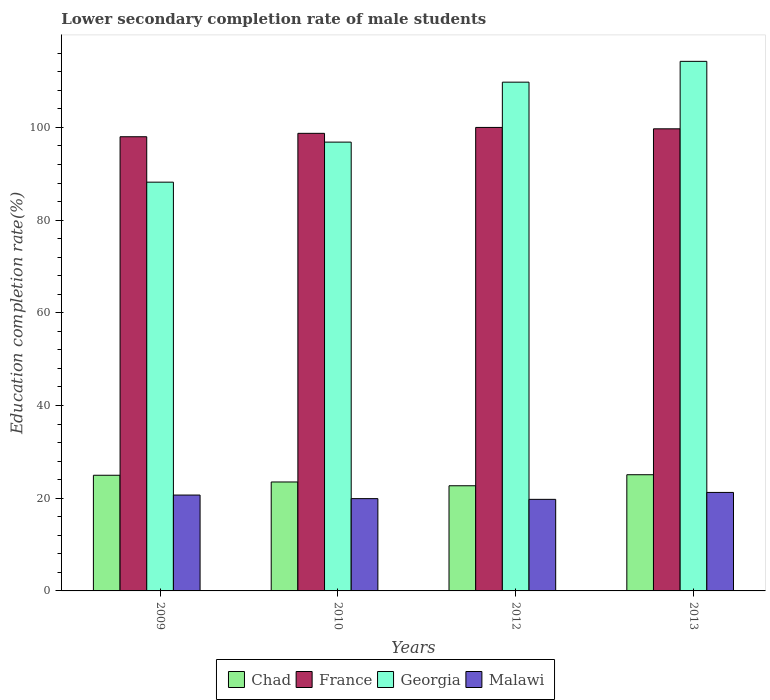Are the number of bars per tick equal to the number of legend labels?
Provide a succinct answer. Yes. Are the number of bars on each tick of the X-axis equal?
Your answer should be compact. Yes. What is the label of the 3rd group of bars from the left?
Provide a short and direct response. 2012. What is the lower secondary completion rate of male students in Malawi in 2009?
Your answer should be compact. 20.68. Across all years, what is the maximum lower secondary completion rate of male students in Chad?
Keep it short and to the point. 25.07. Across all years, what is the minimum lower secondary completion rate of male students in Malawi?
Offer a very short reply. 19.75. In which year was the lower secondary completion rate of male students in Chad maximum?
Your answer should be compact. 2013. What is the total lower secondary completion rate of male students in Chad in the graph?
Provide a short and direct response. 96.22. What is the difference between the lower secondary completion rate of male students in Malawi in 2012 and that in 2013?
Offer a terse response. -1.49. What is the difference between the lower secondary completion rate of male students in France in 2012 and the lower secondary completion rate of male students in Chad in 2013?
Your answer should be compact. 74.93. What is the average lower secondary completion rate of male students in France per year?
Your response must be concise. 99.1. In the year 2009, what is the difference between the lower secondary completion rate of male students in France and lower secondary completion rate of male students in Georgia?
Your answer should be compact. 9.8. What is the ratio of the lower secondary completion rate of male students in Georgia in 2009 to that in 2013?
Your answer should be very brief. 0.77. Is the lower secondary completion rate of male students in Georgia in 2010 less than that in 2013?
Offer a very short reply. Yes. Is the difference between the lower secondary completion rate of male students in France in 2010 and 2013 greater than the difference between the lower secondary completion rate of male students in Georgia in 2010 and 2013?
Offer a very short reply. Yes. What is the difference between the highest and the second highest lower secondary completion rate of male students in Georgia?
Your answer should be compact. 4.49. What is the difference between the highest and the lowest lower secondary completion rate of male students in Chad?
Provide a succinct answer. 2.38. In how many years, is the lower secondary completion rate of male students in Malawi greater than the average lower secondary completion rate of male students in Malawi taken over all years?
Your answer should be compact. 2. Is the sum of the lower secondary completion rate of male students in Chad in 2010 and 2013 greater than the maximum lower secondary completion rate of male students in France across all years?
Make the answer very short. No. What does the 4th bar from the left in 2012 represents?
Make the answer very short. Malawi. What does the 1st bar from the right in 2009 represents?
Your answer should be very brief. Malawi. How many bars are there?
Your response must be concise. 16. Are all the bars in the graph horizontal?
Give a very brief answer. No. How many years are there in the graph?
Offer a very short reply. 4. Does the graph contain any zero values?
Make the answer very short. No. Does the graph contain grids?
Your response must be concise. No. How many legend labels are there?
Give a very brief answer. 4. How are the legend labels stacked?
Ensure brevity in your answer.  Horizontal. What is the title of the graph?
Provide a short and direct response. Lower secondary completion rate of male students. Does "Greenland" appear as one of the legend labels in the graph?
Your answer should be compact. No. What is the label or title of the X-axis?
Make the answer very short. Years. What is the label or title of the Y-axis?
Offer a terse response. Education completion rate(%). What is the Education completion rate(%) of Chad in 2009?
Provide a succinct answer. 24.95. What is the Education completion rate(%) of France in 2009?
Make the answer very short. 97.98. What is the Education completion rate(%) of Georgia in 2009?
Offer a very short reply. 88.19. What is the Education completion rate(%) of Malawi in 2009?
Provide a short and direct response. 20.68. What is the Education completion rate(%) of Chad in 2010?
Your answer should be very brief. 23.51. What is the Education completion rate(%) of France in 2010?
Ensure brevity in your answer.  98.72. What is the Education completion rate(%) of Georgia in 2010?
Your response must be concise. 96.83. What is the Education completion rate(%) of Malawi in 2010?
Offer a very short reply. 19.91. What is the Education completion rate(%) in Chad in 2012?
Your answer should be very brief. 22.69. What is the Education completion rate(%) in France in 2012?
Keep it short and to the point. 99.99. What is the Education completion rate(%) in Georgia in 2012?
Your answer should be very brief. 109.76. What is the Education completion rate(%) in Malawi in 2012?
Your response must be concise. 19.75. What is the Education completion rate(%) of Chad in 2013?
Your answer should be very brief. 25.07. What is the Education completion rate(%) of France in 2013?
Your answer should be very brief. 99.7. What is the Education completion rate(%) of Georgia in 2013?
Give a very brief answer. 114.25. What is the Education completion rate(%) in Malawi in 2013?
Your answer should be very brief. 21.25. Across all years, what is the maximum Education completion rate(%) in Chad?
Your answer should be compact. 25.07. Across all years, what is the maximum Education completion rate(%) of France?
Offer a very short reply. 99.99. Across all years, what is the maximum Education completion rate(%) in Georgia?
Give a very brief answer. 114.25. Across all years, what is the maximum Education completion rate(%) in Malawi?
Your response must be concise. 21.25. Across all years, what is the minimum Education completion rate(%) of Chad?
Offer a terse response. 22.69. Across all years, what is the minimum Education completion rate(%) in France?
Offer a terse response. 97.98. Across all years, what is the minimum Education completion rate(%) in Georgia?
Ensure brevity in your answer.  88.19. Across all years, what is the minimum Education completion rate(%) of Malawi?
Keep it short and to the point. 19.75. What is the total Education completion rate(%) of Chad in the graph?
Your answer should be very brief. 96.22. What is the total Education completion rate(%) in France in the graph?
Offer a very short reply. 396.4. What is the total Education completion rate(%) in Georgia in the graph?
Offer a terse response. 409.02. What is the total Education completion rate(%) in Malawi in the graph?
Make the answer very short. 81.6. What is the difference between the Education completion rate(%) of Chad in 2009 and that in 2010?
Offer a very short reply. 1.45. What is the difference between the Education completion rate(%) of France in 2009 and that in 2010?
Give a very brief answer. -0.74. What is the difference between the Education completion rate(%) in Georgia in 2009 and that in 2010?
Make the answer very short. -8.64. What is the difference between the Education completion rate(%) of Malawi in 2009 and that in 2010?
Offer a very short reply. 0.77. What is the difference between the Education completion rate(%) of Chad in 2009 and that in 2012?
Your response must be concise. 2.27. What is the difference between the Education completion rate(%) of France in 2009 and that in 2012?
Your response must be concise. -2.01. What is the difference between the Education completion rate(%) in Georgia in 2009 and that in 2012?
Provide a succinct answer. -21.57. What is the difference between the Education completion rate(%) of Malawi in 2009 and that in 2012?
Keep it short and to the point. 0.93. What is the difference between the Education completion rate(%) in Chad in 2009 and that in 2013?
Ensure brevity in your answer.  -0.11. What is the difference between the Education completion rate(%) in France in 2009 and that in 2013?
Make the answer very short. -1.71. What is the difference between the Education completion rate(%) of Georgia in 2009 and that in 2013?
Your answer should be very brief. -26.07. What is the difference between the Education completion rate(%) of Malawi in 2009 and that in 2013?
Provide a short and direct response. -0.57. What is the difference between the Education completion rate(%) in Chad in 2010 and that in 2012?
Your answer should be very brief. 0.82. What is the difference between the Education completion rate(%) in France in 2010 and that in 2012?
Make the answer very short. -1.27. What is the difference between the Education completion rate(%) in Georgia in 2010 and that in 2012?
Your response must be concise. -12.93. What is the difference between the Education completion rate(%) of Malawi in 2010 and that in 2012?
Your answer should be very brief. 0.16. What is the difference between the Education completion rate(%) of Chad in 2010 and that in 2013?
Keep it short and to the point. -1.56. What is the difference between the Education completion rate(%) in France in 2010 and that in 2013?
Provide a succinct answer. -0.98. What is the difference between the Education completion rate(%) of Georgia in 2010 and that in 2013?
Ensure brevity in your answer.  -17.42. What is the difference between the Education completion rate(%) in Malawi in 2010 and that in 2013?
Keep it short and to the point. -1.34. What is the difference between the Education completion rate(%) in Chad in 2012 and that in 2013?
Provide a succinct answer. -2.38. What is the difference between the Education completion rate(%) of France in 2012 and that in 2013?
Offer a very short reply. 0.3. What is the difference between the Education completion rate(%) of Georgia in 2012 and that in 2013?
Make the answer very short. -4.49. What is the difference between the Education completion rate(%) of Malawi in 2012 and that in 2013?
Offer a terse response. -1.49. What is the difference between the Education completion rate(%) in Chad in 2009 and the Education completion rate(%) in France in 2010?
Your answer should be compact. -73.77. What is the difference between the Education completion rate(%) in Chad in 2009 and the Education completion rate(%) in Georgia in 2010?
Offer a very short reply. -71.87. What is the difference between the Education completion rate(%) of Chad in 2009 and the Education completion rate(%) of Malawi in 2010?
Offer a very short reply. 5.04. What is the difference between the Education completion rate(%) in France in 2009 and the Education completion rate(%) in Georgia in 2010?
Offer a very short reply. 1.16. What is the difference between the Education completion rate(%) in France in 2009 and the Education completion rate(%) in Malawi in 2010?
Keep it short and to the point. 78.07. What is the difference between the Education completion rate(%) of Georgia in 2009 and the Education completion rate(%) of Malawi in 2010?
Your answer should be very brief. 68.27. What is the difference between the Education completion rate(%) in Chad in 2009 and the Education completion rate(%) in France in 2012?
Offer a terse response. -75.04. What is the difference between the Education completion rate(%) in Chad in 2009 and the Education completion rate(%) in Georgia in 2012?
Your answer should be compact. -84.81. What is the difference between the Education completion rate(%) in Chad in 2009 and the Education completion rate(%) in Malawi in 2012?
Keep it short and to the point. 5.2. What is the difference between the Education completion rate(%) of France in 2009 and the Education completion rate(%) of Georgia in 2012?
Your answer should be very brief. -11.78. What is the difference between the Education completion rate(%) in France in 2009 and the Education completion rate(%) in Malawi in 2012?
Provide a short and direct response. 78.23. What is the difference between the Education completion rate(%) in Georgia in 2009 and the Education completion rate(%) in Malawi in 2012?
Your answer should be compact. 68.43. What is the difference between the Education completion rate(%) of Chad in 2009 and the Education completion rate(%) of France in 2013?
Your answer should be very brief. -74.74. What is the difference between the Education completion rate(%) in Chad in 2009 and the Education completion rate(%) in Georgia in 2013?
Ensure brevity in your answer.  -89.3. What is the difference between the Education completion rate(%) of Chad in 2009 and the Education completion rate(%) of Malawi in 2013?
Ensure brevity in your answer.  3.71. What is the difference between the Education completion rate(%) of France in 2009 and the Education completion rate(%) of Georgia in 2013?
Your answer should be very brief. -16.27. What is the difference between the Education completion rate(%) of France in 2009 and the Education completion rate(%) of Malawi in 2013?
Make the answer very short. 76.74. What is the difference between the Education completion rate(%) of Georgia in 2009 and the Education completion rate(%) of Malawi in 2013?
Keep it short and to the point. 66.94. What is the difference between the Education completion rate(%) in Chad in 2010 and the Education completion rate(%) in France in 2012?
Your response must be concise. -76.49. What is the difference between the Education completion rate(%) in Chad in 2010 and the Education completion rate(%) in Georgia in 2012?
Make the answer very short. -86.25. What is the difference between the Education completion rate(%) of Chad in 2010 and the Education completion rate(%) of Malawi in 2012?
Keep it short and to the point. 3.75. What is the difference between the Education completion rate(%) in France in 2010 and the Education completion rate(%) in Georgia in 2012?
Make the answer very short. -11.04. What is the difference between the Education completion rate(%) of France in 2010 and the Education completion rate(%) of Malawi in 2012?
Give a very brief answer. 78.97. What is the difference between the Education completion rate(%) of Georgia in 2010 and the Education completion rate(%) of Malawi in 2012?
Your answer should be very brief. 77.07. What is the difference between the Education completion rate(%) of Chad in 2010 and the Education completion rate(%) of France in 2013?
Your answer should be compact. -76.19. What is the difference between the Education completion rate(%) of Chad in 2010 and the Education completion rate(%) of Georgia in 2013?
Provide a short and direct response. -90.74. What is the difference between the Education completion rate(%) in Chad in 2010 and the Education completion rate(%) in Malawi in 2013?
Your answer should be very brief. 2.26. What is the difference between the Education completion rate(%) of France in 2010 and the Education completion rate(%) of Georgia in 2013?
Offer a terse response. -15.53. What is the difference between the Education completion rate(%) in France in 2010 and the Education completion rate(%) in Malawi in 2013?
Offer a terse response. 77.47. What is the difference between the Education completion rate(%) in Georgia in 2010 and the Education completion rate(%) in Malawi in 2013?
Your answer should be very brief. 75.58. What is the difference between the Education completion rate(%) of Chad in 2012 and the Education completion rate(%) of France in 2013?
Your answer should be compact. -77.01. What is the difference between the Education completion rate(%) in Chad in 2012 and the Education completion rate(%) in Georgia in 2013?
Your answer should be compact. -91.56. What is the difference between the Education completion rate(%) in Chad in 2012 and the Education completion rate(%) in Malawi in 2013?
Ensure brevity in your answer.  1.44. What is the difference between the Education completion rate(%) of France in 2012 and the Education completion rate(%) of Georgia in 2013?
Offer a very short reply. -14.26. What is the difference between the Education completion rate(%) of France in 2012 and the Education completion rate(%) of Malawi in 2013?
Ensure brevity in your answer.  78.75. What is the difference between the Education completion rate(%) of Georgia in 2012 and the Education completion rate(%) of Malawi in 2013?
Your answer should be very brief. 88.51. What is the average Education completion rate(%) of Chad per year?
Offer a terse response. 24.05. What is the average Education completion rate(%) of France per year?
Keep it short and to the point. 99.1. What is the average Education completion rate(%) of Georgia per year?
Ensure brevity in your answer.  102.26. What is the average Education completion rate(%) in Malawi per year?
Offer a terse response. 20.4. In the year 2009, what is the difference between the Education completion rate(%) of Chad and Education completion rate(%) of France?
Provide a succinct answer. -73.03. In the year 2009, what is the difference between the Education completion rate(%) in Chad and Education completion rate(%) in Georgia?
Give a very brief answer. -63.23. In the year 2009, what is the difference between the Education completion rate(%) in Chad and Education completion rate(%) in Malawi?
Offer a very short reply. 4.27. In the year 2009, what is the difference between the Education completion rate(%) in France and Education completion rate(%) in Georgia?
Give a very brief answer. 9.8. In the year 2009, what is the difference between the Education completion rate(%) of France and Education completion rate(%) of Malawi?
Provide a short and direct response. 77.3. In the year 2009, what is the difference between the Education completion rate(%) in Georgia and Education completion rate(%) in Malawi?
Make the answer very short. 67.5. In the year 2010, what is the difference between the Education completion rate(%) in Chad and Education completion rate(%) in France?
Provide a short and direct response. -75.22. In the year 2010, what is the difference between the Education completion rate(%) in Chad and Education completion rate(%) in Georgia?
Keep it short and to the point. -73.32. In the year 2010, what is the difference between the Education completion rate(%) in Chad and Education completion rate(%) in Malawi?
Ensure brevity in your answer.  3.59. In the year 2010, what is the difference between the Education completion rate(%) of France and Education completion rate(%) of Georgia?
Your answer should be compact. 1.89. In the year 2010, what is the difference between the Education completion rate(%) of France and Education completion rate(%) of Malawi?
Ensure brevity in your answer.  78.81. In the year 2010, what is the difference between the Education completion rate(%) in Georgia and Education completion rate(%) in Malawi?
Give a very brief answer. 76.91. In the year 2012, what is the difference between the Education completion rate(%) in Chad and Education completion rate(%) in France?
Keep it short and to the point. -77.31. In the year 2012, what is the difference between the Education completion rate(%) in Chad and Education completion rate(%) in Georgia?
Your answer should be very brief. -87.07. In the year 2012, what is the difference between the Education completion rate(%) of Chad and Education completion rate(%) of Malawi?
Make the answer very short. 2.93. In the year 2012, what is the difference between the Education completion rate(%) in France and Education completion rate(%) in Georgia?
Offer a very short reply. -9.77. In the year 2012, what is the difference between the Education completion rate(%) of France and Education completion rate(%) of Malawi?
Give a very brief answer. 80.24. In the year 2012, what is the difference between the Education completion rate(%) of Georgia and Education completion rate(%) of Malawi?
Make the answer very short. 90.01. In the year 2013, what is the difference between the Education completion rate(%) of Chad and Education completion rate(%) of France?
Ensure brevity in your answer.  -74.63. In the year 2013, what is the difference between the Education completion rate(%) of Chad and Education completion rate(%) of Georgia?
Give a very brief answer. -89.18. In the year 2013, what is the difference between the Education completion rate(%) in Chad and Education completion rate(%) in Malawi?
Give a very brief answer. 3.82. In the year 2013, what is the difference between the Education completion rate(%) in France and Education completion rate(%) in Georgia?
Your answer should be very brief. -14.55. In the year 2013, what is the difference between the Education completion rate(%) of France and Education completion rate(%) of Malawi?
Make the answer very short. 78.45. In the year 2013, what is the difference between the Education completion rate(%) of Georgia and Education completion rate(%) of Malawi?
Ensure brevity in your answer.  93. What is the ratio of the Education completion rate(%) of Chad in 2009 to that in 2010?
Make the answer very short. 1.06. What is the ratio of the Education completion rate(%) in Georgia in 2009 to that in 2010?
Provide a succinct answer. 0.91. What is the ratio of the Education completion rate(%) of Malawi in 2009 to that in 2010?
Keep it short and to the point. 1.04. What is the ratio of the Education completion rate(%) of Chad in 2009 to that in 2012?
Provide a succinct answer. 1.1. What is the ratio of the Education completion rate(%) in France in 2009 to that in 2012?
Offer a very short reply. 0.98. What is the ratio of the Education completion rate(%) of Georgia in 2009 to that in 2012?
Offer a terse response. 0.8. What is the ratio of the Education completion rate(%) of Malawi in 2009 to that in 2012?
Provide a succinct answer. 1.05. What is the ratio of the Education completion rate(%) in France in 2009 to that in 2013?
Offer a terse response. 0.98. What is the ratio of the Education completion rate(%) of Georgia in 2009 to that in 2013?
Offer a terse response. 0.77. What is the ratio of the Education completion rate(%) of Malawi in 2009 to that in 2013?
Ensure brevity in your answer.  0.97. What is the ratio of the Education completion rate(%) of Chad in 2010 to that in 2012?
Your response must be concise. 1.04. What is the ratio of the Education completion rate(%) of France in 2010 to that in 2012?
Your answer should be very brief. 0.99. What is the ratio of the Education completion rate(%) in Georgia in 2010 to that in 2012?
Offer a terse response. 0.88. What is the ratio of the Education completion rate(%) of Malawi in 2010 to that in 2012?
Keep it short and to the point. 1.01. What is the ratio of the Education completion rate(%) of Chad in 2010 to that in 2013?
Offer a very short reply. 0.94. What is the ratio of the Education completion rate(%) in France in 2010 to that in 2013?
Your response must be concise. 0.99. What is the ratio of the Education completion rate(%) of Georgia in 2010 to that in 2013?
Your response must be concise. 0.85. What is the ratio of the Education completion rate(%) of Malawi in 2010 to that in 2013?
Your response must be concise. 0.94. What is the ratio of the Education completion rate(%) of Chad in 2012 to that in 2013?
Your response must be concise. 0.91. What is the ratio of the Education completion rate(%) in France in 2012 to that in 2013?
Keep it short and to the point. 1. What is the ratio of the Education completion rate(%) of Georgia in 2012 to that in 2013?
Your response must be concise. 0.96. What is the ratio of the Education completion rate(%) in Malawi in 2012 to that in 2013?
Make the answer very short. 0.93. What is the difference between the highest and the second highest Education completion rate(%) in Chad?
Provide a succinct answer. 0.11. What is the difference between the highest and the second highest Education completion rate(%) of France?
Your response must be concise. 0.3. What is the difference between the highest and the second highest Education completion rate(%) in Georgia?
Your answer should be compact. 4.49. What is the difference between the highest and the second highest Education completion rate(%) in Malawi?
Keep it short and to the point. 0.57. What is the difference between the highest and the lowest Education completion rate(%) of Chad?
Provide a short and direct response. 2.38. What is the difference between the highest and the lowest Education completion rate(%) in France?
Your answer should be very brief. 2.01. What is the difference between the highest and the lowest Education completion rate(%) in Georgia?
Make the answer very short. 26.07. What is the difference between the highest and the lowest Education completion rate(%) in Malawi?
Offer a terse response. 1.49. 